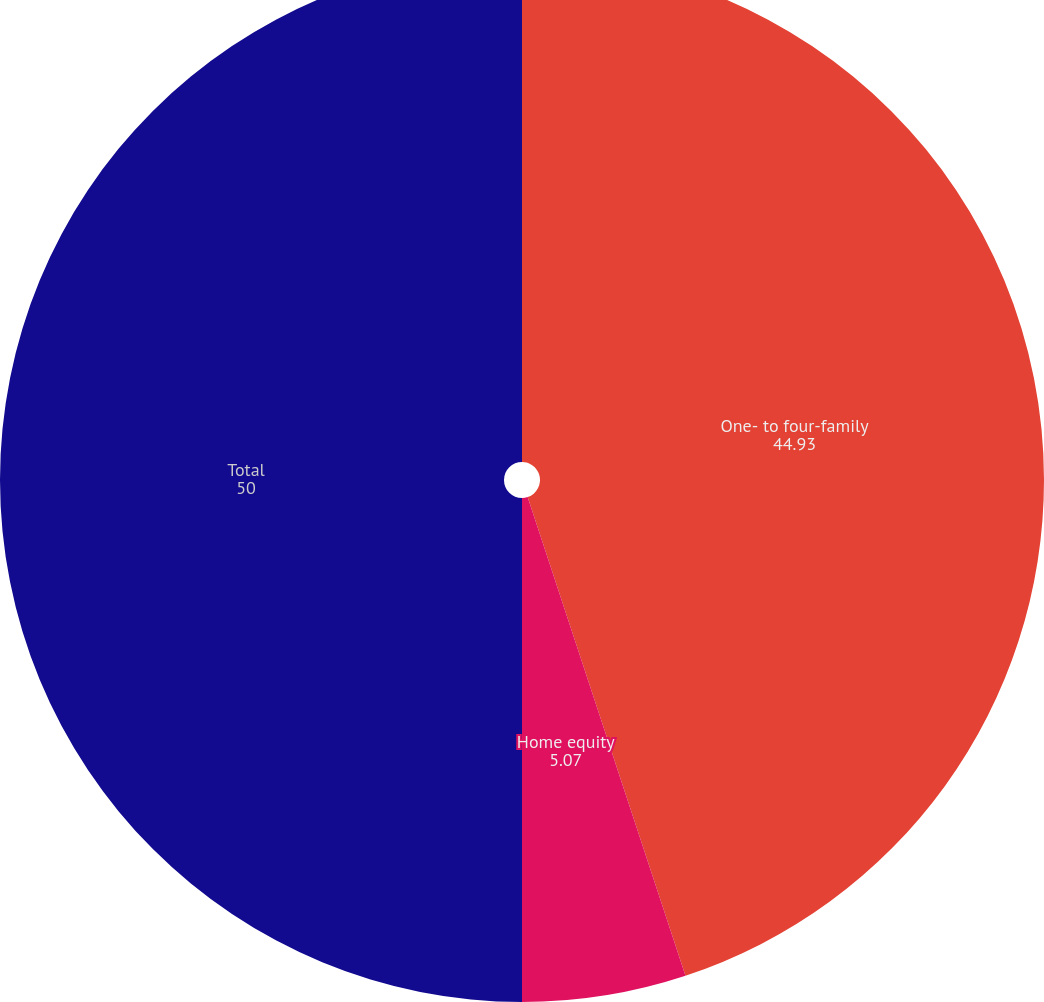Convert chart. <chart><loc_0><loc_0><loc_500><loc_500><pie_chart><fcel>One- to four-family<fcel>Home equity<fcel>Total<nl><fcel>44.93%<fcel>5.07%<fcel>50.0%<nl></chart> 